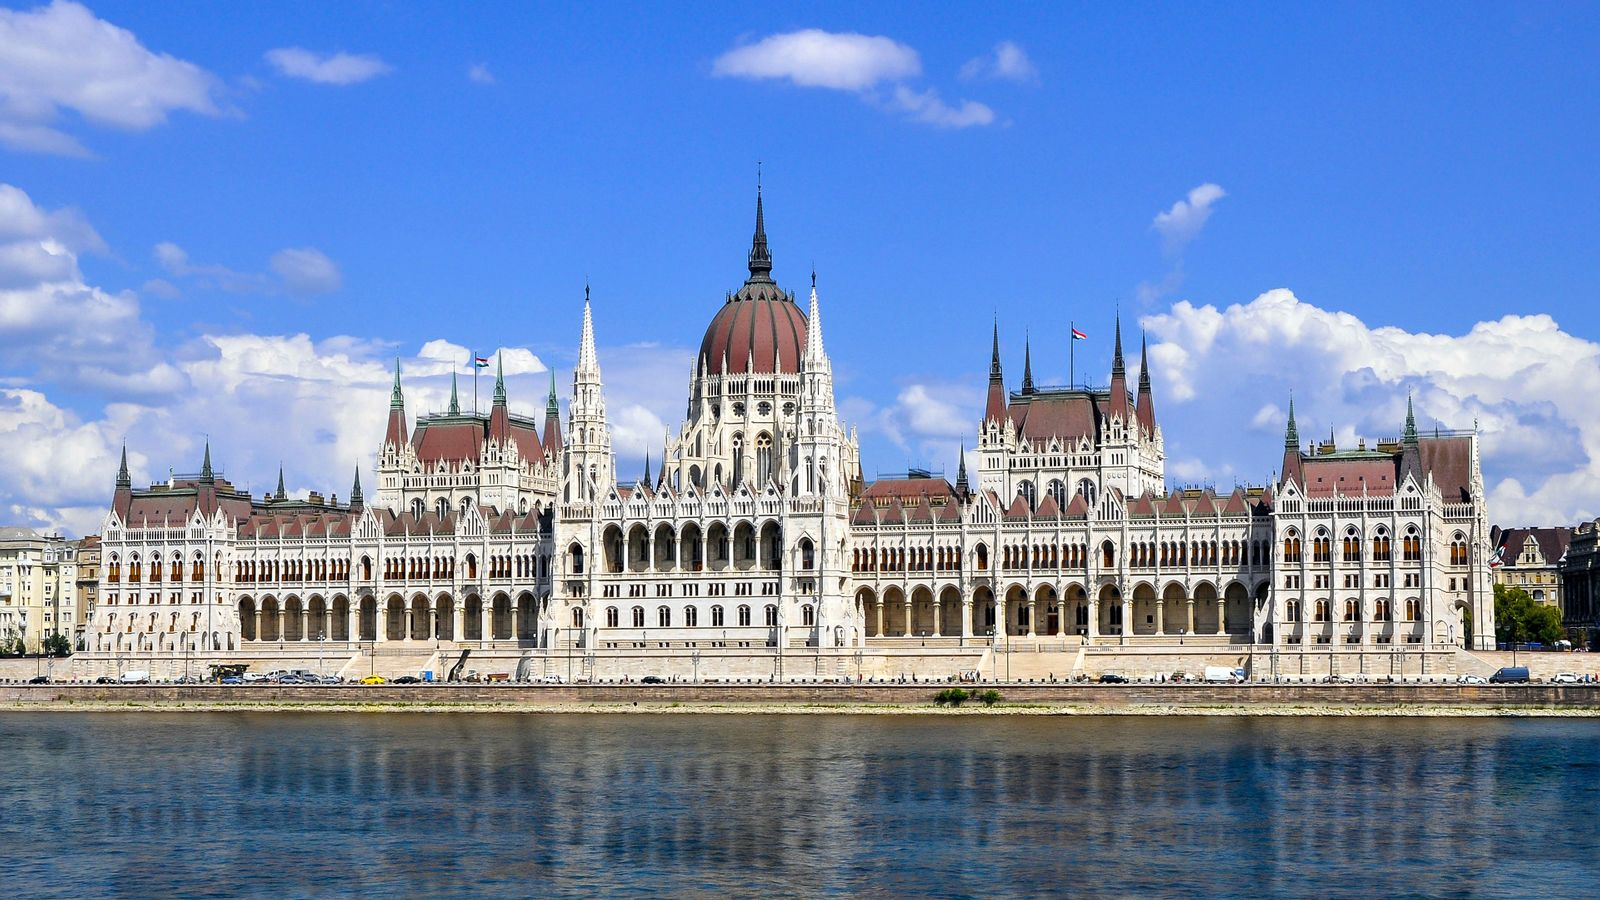Imagine the Hungarian Parliament Building could talk. What stories would it tell? If the Hungarian Parliament Building could talk, it would narrate tales of empires and kings, revolutions and reforms, and the unfolding history of Hungary. It would tell stories of the fervent debates within its walls, where the fate of the nation was decided. The building would recount the grandeur of royal visits and state ceremonies, echoing with the voices of those who have walked its halls. It would speak of resilience and restoration, having witnessed both the wars that sought to destroy it and the peace that allowed it to stand proudly again. The Parliament Building would share the rich tapestry of Hungary's past, woven with threads of culture, politics, and the enduring spirit of its people. 